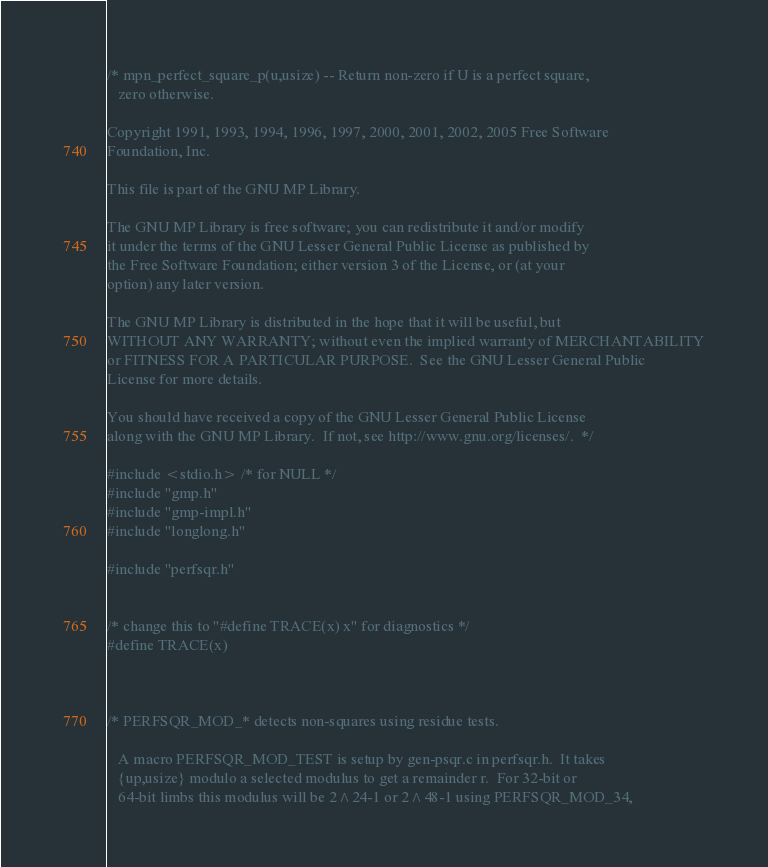<code> <loc_0><loc_0><loc_500><loc_500><_C_>/* mpn_perfect_square_p(u,usize) -- Return non-zero if U is a perfect square,
   zero otherwise.

Copyright 1991, 1993, 1994, 1996, 1997, 2000, 2001, 2002, 2005 Free Software
Foundation, Inc.

This file is part of the GNU MP Library.

The GNU MP Library is free software; you can redistribute it and/or modify
it under the terms of the GNU Lesser General Public License as published by
the Free Software Foundation; either version 3 of the License, or (at your
option) any later version.

The GNU MP Library is distributed in the hope that it will be useful, but
WITHOUT ANY WARRANTY; without even the implied warranty of MERCHANTABILITY
or FITNESS FOR A PARTICULAR PURPOSE.  See the GNU Lesser General Public
License for more details.

You should have received a copy of the GNU Lesser General Public License
along with the GNU MP Library.  If not, see http://www.gnu.org/licenses/.  */

#include <stdio.h> /* for NULL */
#include "gmp.h"
#include "gmp-impl.h"
#include "longlong.h"

#include "perfsqr.h"


/* change this to "#define TRACE(x) x" for diagnostics */
#define TRACE(x)



/* PERFSQR_MOD_* detects non-squares using residue tests.

   A macro PERFSQR_MOD_TEST is setup by gen-psqr.c in perfsqr.h.  It takes
   {up,usize} modulo a selected modulus to get a remainder r.  For 32-bit or
   64-bit limbs this modulus will be 2^24-1 or 2^48-1 using PERFSQR_MOD_34,</code> 